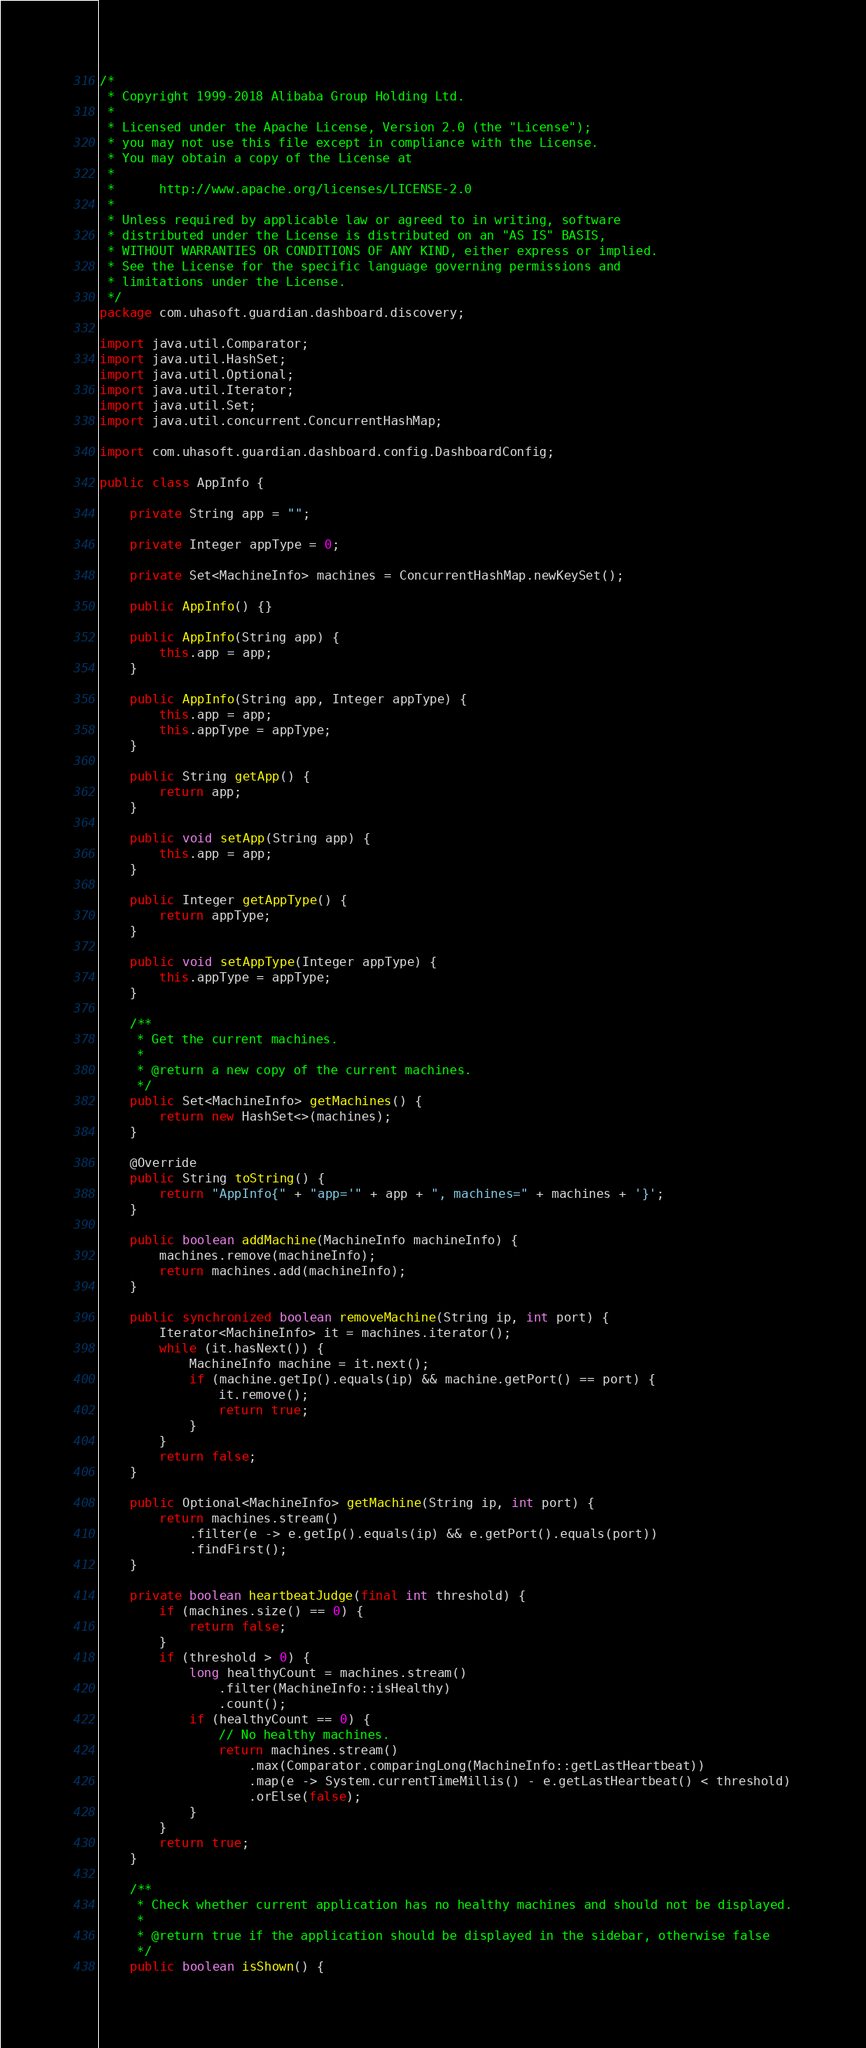<code> <loc_0><loc_0><loc_500><loc_500><_Java_>/*
 * Copyright 1999-2018 Alibaba Group Holding Ltd.
 *
 * Licensed under the Apache License, Version 2.0 (the "License");
 * you may not use this file except in compliance with the License.
 * You may obtain a copy of the License at
 *
 *      http://www.apache.org/licenses/LICENSE-2.0
 *
 * Unless required by applicable law or agreed to in writing, software
 * distributed under the License is distributed on an "AS IS" BASIS,
 * WITHOUT WARRANTIES OR CONDITIONS OF ANY KIND, either express or implied.
 * See the License for the specific language governing permissions and
 * limitations under the License.
 */
package com.uhasoft.guardian.dashboard.discovery;

import java.util.Comparator;
import java.util.HashSet;
import java.util.Optional;
import java.util.Iterator;
import java.util.Set;
import java.util.concurrent.ConcurrentHashMap;

import com.uhasoft.guardian.dashboard.config.DashboardConfig;

public class AppInfo {

    private String app = "";

    private Integer appType = 0;

    private Set<MachineInfo> machines = ConcurrentHashMap.newKeySet();

    public AppInfo() {}

    public AppInfo(String app) {
        this.app = app;
    }

    public AppInfo(String app, Integer appType) {
        this.app = app;
        this.appType = appType;
    }

    public String getApp() {
        return app;
    }

    public void setApp(String app) {
        this.app = app;
    }

    public Integer getAppType() {
        return appType;
    }

    public void setAppType(Integer appType) {
        this.appType = appType;
    }

    /**
     * Get the current machines.
     *
     * @return a new copy of the current machines.
     */
    public Set<MachineInfo> getMachines() {
        return new HashSet<>(machines);
    }

    @Override
    public String toString() {
        return "AppInfo{" + "app='" + app + ", machines=" + machines + '}';
    }

    public boolean addMachine(MachineInfo machineInfo) {
        machines.remove(machineInfo);
        return machines.add(machineInfo);
    }

    public synchronized boolean removeMachine(String ip, int port) {
        Iterator<MachineInfo> it = machines.iterator();
        while (it.hasNext()) {
            MachineInfo machine = it.next();
            if (machine.getIp().equals(ip) && machine.getPort() == port) {
                it.remove();
                return true;
            }
        }
        return false;
    }

    public Optional<MachineInfo> getMachine(String ip, int port) {
        return machines.stream()
            .filter(e -> e.getIp().equals(ip) && e.getPort().equals(port))
            .findFirst();
    }

    private boolean heartbeatJudge(final int threshold) {
        if (machines.size() == 0) {
            return false;
        }
        if (threshold > 0) {
            long healthyCount = machines.stream()
                .filter(MachineInfo::isHealthy)
                .count();
            if (healthyCount == 0) {
                // No healthy machines.
                return machines.stream()
                    .max(Comparator.comparingLong(MachineInfo::getLastHeartbeat))
                    .map(e -> System.currentTimeMillis() - e.getLastHeartbeat() < threshold)
                    .orElse(false);
            }
        }
        return true;
    }

    /**
     * Check whether current application has no healthy machines and should not be displayed.
     *
     * @return true if the application should be displayed in the sidebar, otherwise false
     */
    public boolean isShown() {</code> 